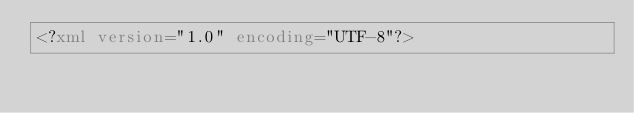<code> <loc_0><loc_0><loc_500><loc_500><_XML_><?xml version="1.0" encoding="UTF-8"?></code> 